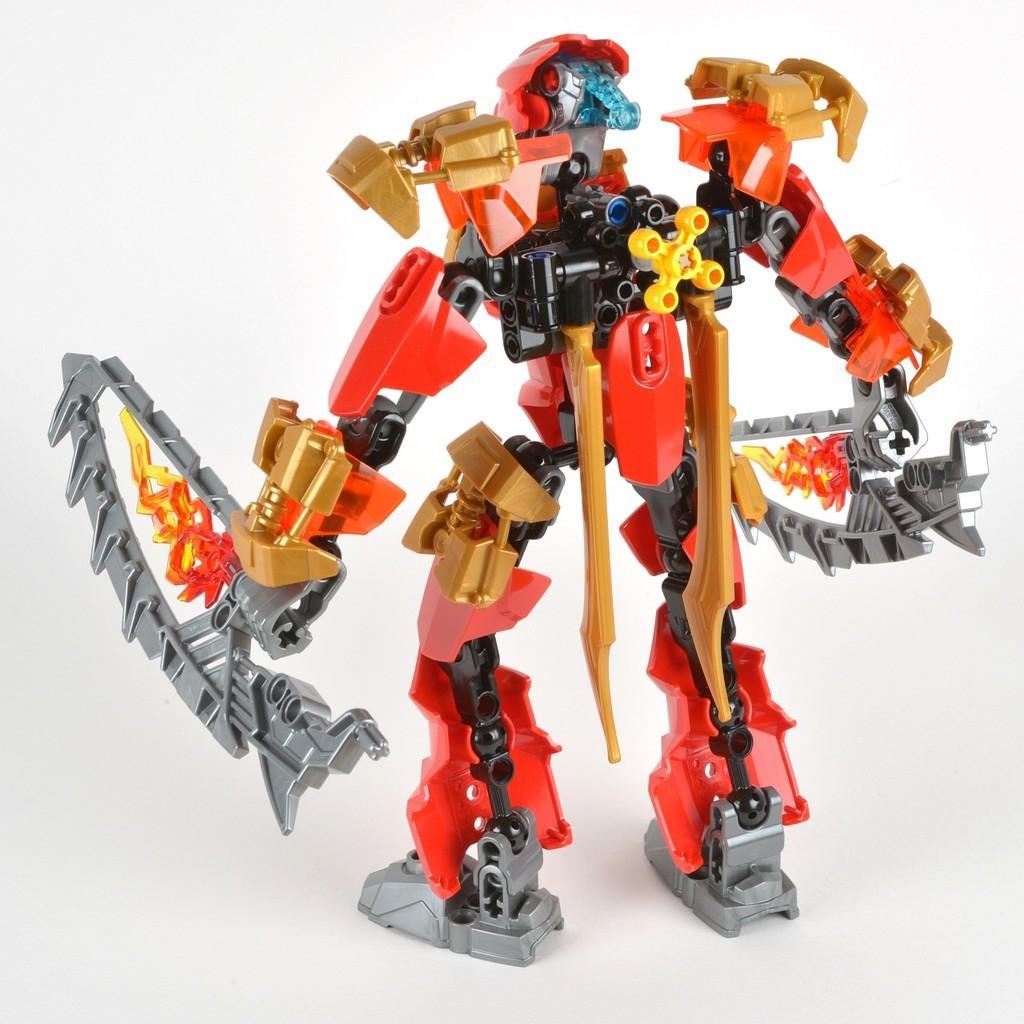In one or two sentences, can you explain what this image depicts? In this image I can see e robot toy. The background is in white color. 